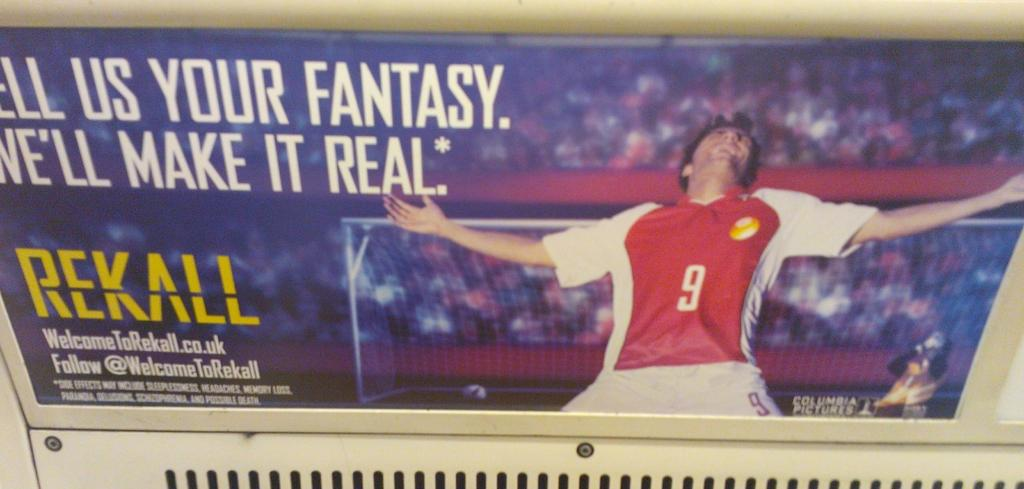<image>
Write a terse but informative summary of the picture. An ad that says "Tell us your fantasy. We'll make it real." 